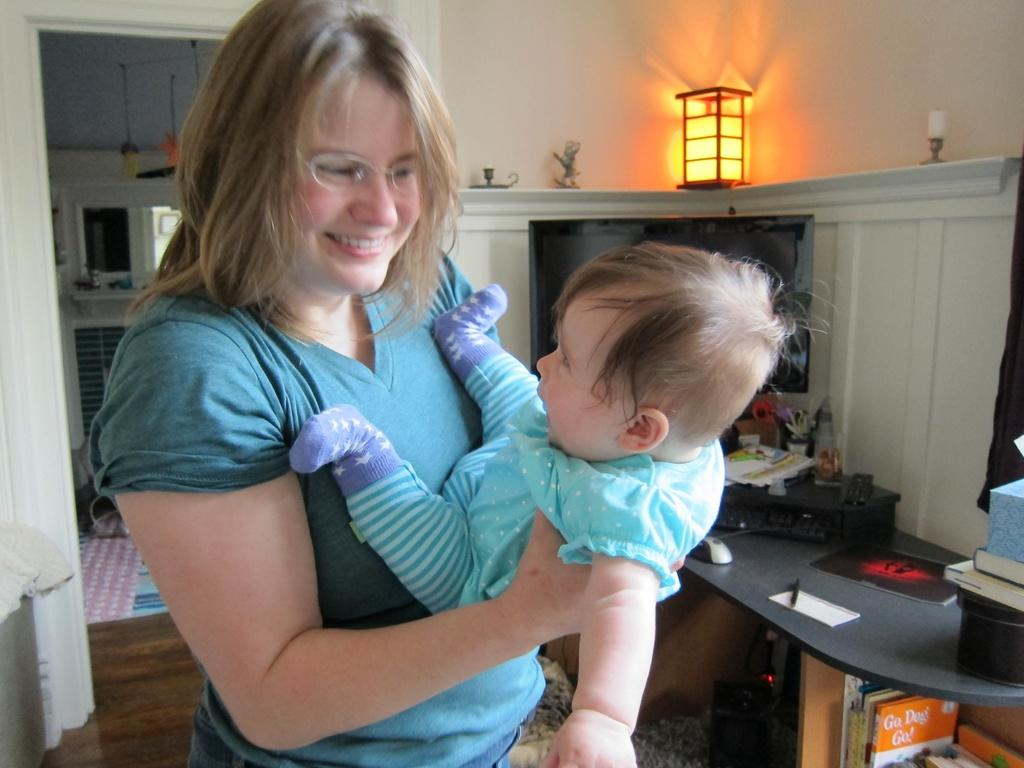Who is present in the image? There is a woman in the image. What is the woman doing? The woman is smiling. What is the emotional state of the child in the image? The child is crying. How is the woman interacting with the child? The woman's hand is touching the child. What can be seen in the background of the image? There is a window, a light, a cupboard, a table, a mouse, sheets, and books in the background of the image. What type of wing is visible in the image? There is no wing present in the image. Is there any steam coming from the books in the image? There is no steam visible in the image. 